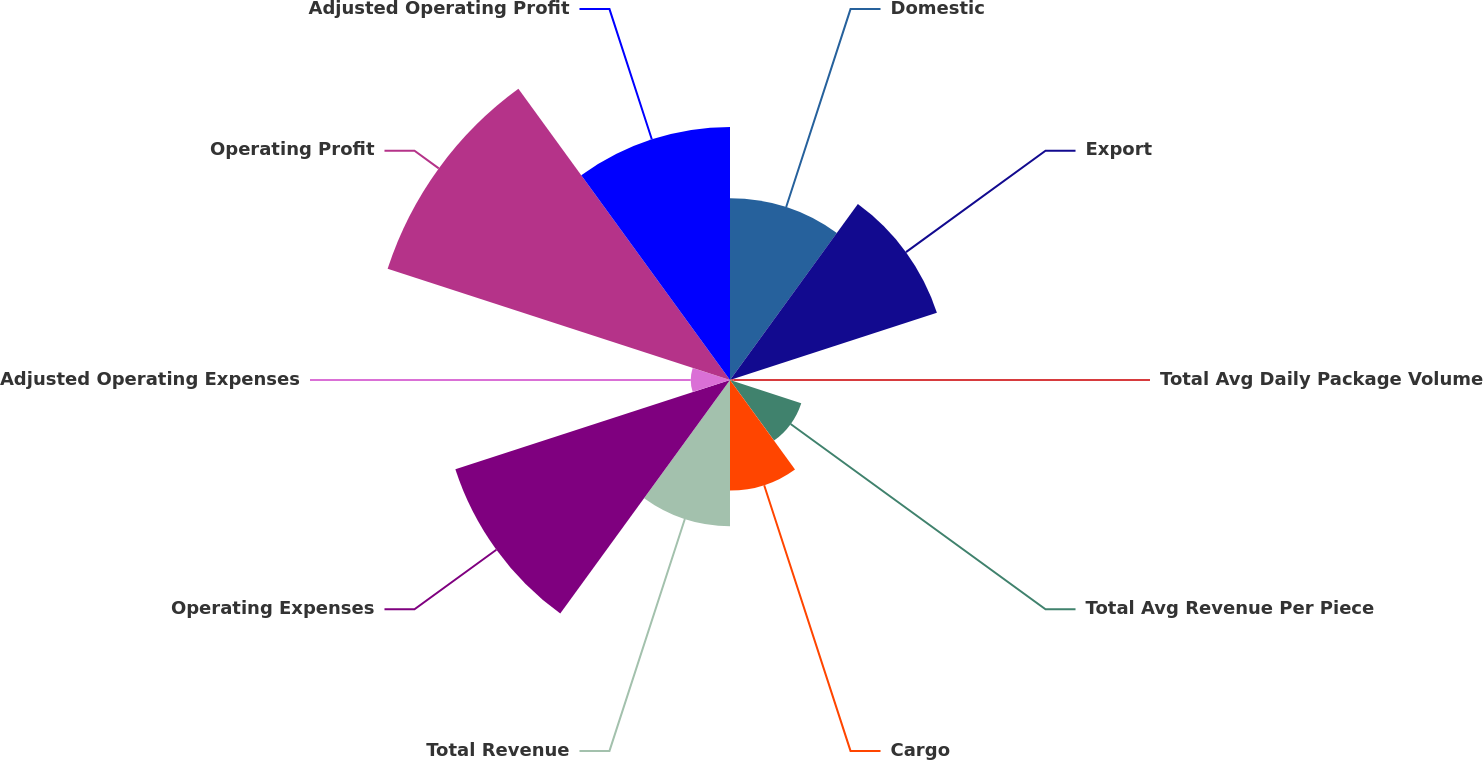Convert chart. <chart><loc_0><loc_0><loc_500><loc_500><pie_chart><fcel>Domestic<fcel>Export<fcel>Total Avg Daily Package Volume<fcel>Total Avg Revenue Per Piece<fcel>Cargo<fcel>Total Revenue<fcel>Operating Expenses<fcel>Adjusted Operating Expenses<fcel>Operating Profit<fcel>Adjusted Operating Profit<nl><fcel>10.85%<fcel>12.98%<fcel>0.22%<fcel>4.47%<fcel>6.6%<fcel>8.72%<fcel>17.23%<fcel>2.34%<fcel>21.48%<fcel>15.1%<nl></chart> 